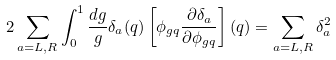<formula> <loc_0><loc_0><loc_500><loc_500>2 \sum _ { a = L , R } \int _ { 0 } ^ { 1 } \frac { d g } { g } \delta _ { a } ( q ) \left [ \phi _ { g q } \frac { \partial \delta _ { a } } { \partial \phi _ { g q } } \right ] ( q ) = \sum _ { a = L , R } \delta _ { a } ^ { 2 }</formula> 